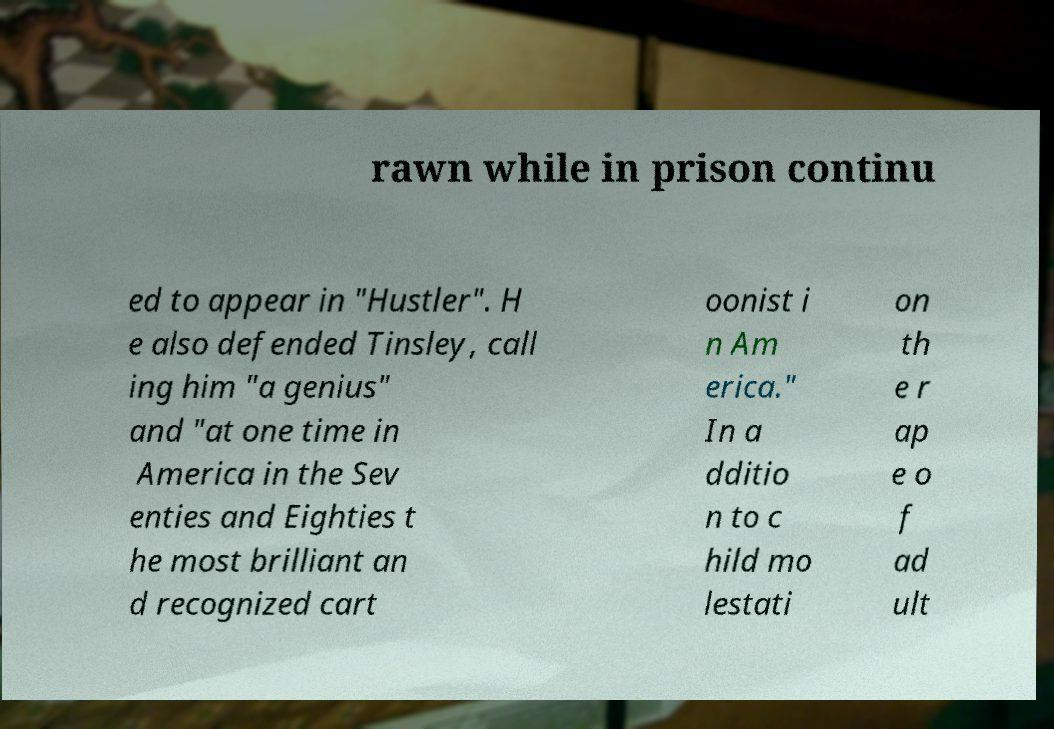Can you read and provide the text displayed in the image?This photo seems to have some interesting text. Can you extract and type it out for me? rawn while in prison continu ed to appear in "Hustler". H e also defended Tinsley, call ing him "a genius" and "at one time in America in the Sev enties and Eighties t he most brilliant an d recognized cart oonist i n Am erica." In a dditio n to c hild mo lestati on th e r ap e o f ad ult 